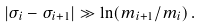<formula> <loc_0><loc_0><loc_500><loc_500>| \sigma _ { i } - \sigma _ { i + 1 } | \gg \ln ( m _ { i { + } 1 } / m _ { i } ) \, .</formula> 